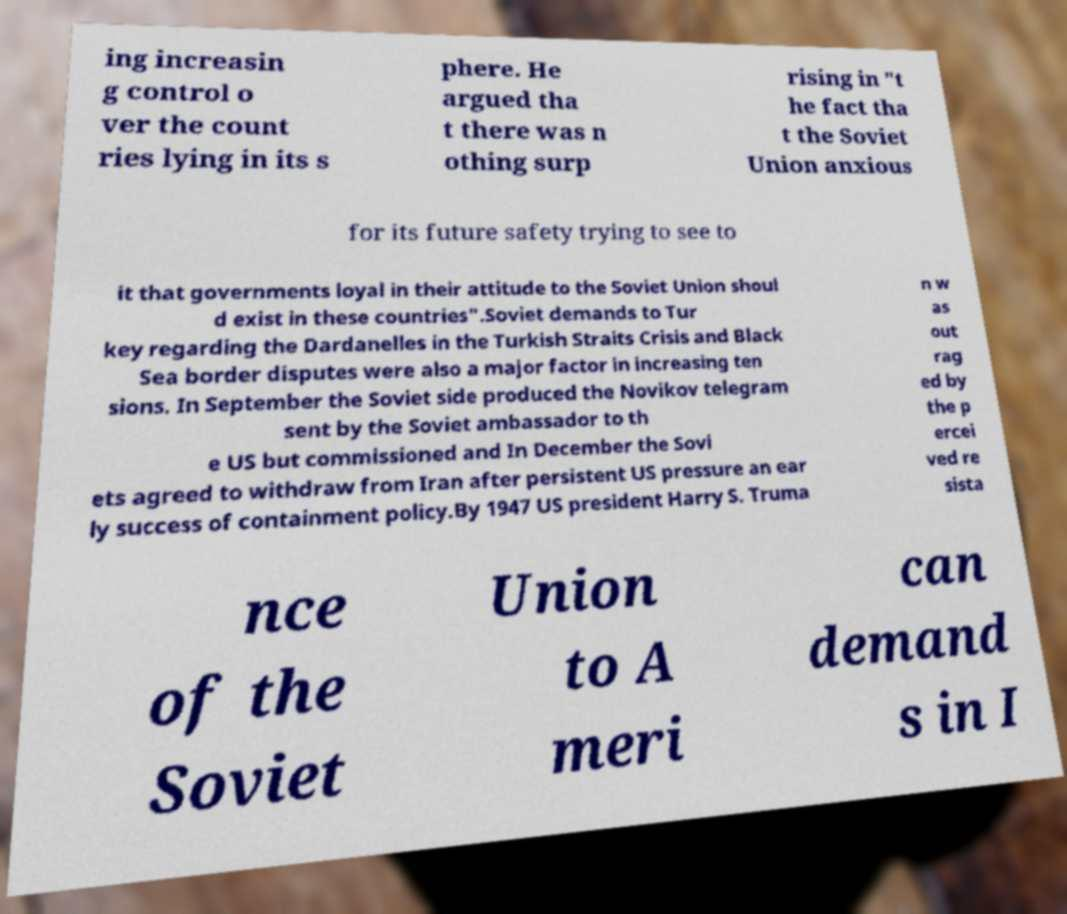Please read and relay the text visible in this image. What does it say? ing increasin g control o ver the count ries lying in its s phere. He argued tha t there was n othing surp rising in "t he fact tha t the Soviet Union anxious for its future safety trying to see to it that governments loyal in their attitude to the Soviet Union shoul d exist in these countries".Soviet demands to Tur key regarding the Dardanelles in the Turkish Straits Crisis and Black Sea border disputes were also a major factor in increasing ten sions. In September the Soviet side produced the Novikov telegram sent by the Soviet ambassador to th e US but commissioned and In December the Sovi ets agreed to withdraw from Iran after persistent US pressure an ear ly success of containment policy.By 1947 US president Harry S. Truma n w as out rag ed by the p ercei ved re sista nce of the Soviet Union to A meri can demand s in I 